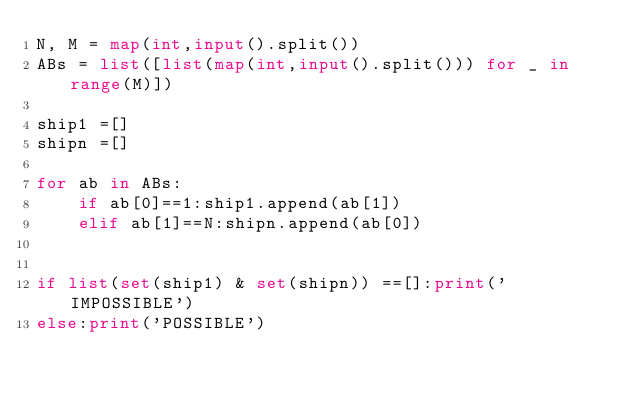Convert code to text. <code><loc_0><loc_0><loc_500><loc_500><_Python_>N, M = map(int,input().split())
ABs = list([list(map(int,input().split())) for _ in range(M)])
 
ship1 =[]
shipn =[]
 
for ab in ABs:
    if ab[0]==1:ship1.append(ab[1])
    elif ab[1]==N:shipn.append(ab[0])
 
      
if list(set(ship1) & set(shipn)) ==[]:print('IMPOSSIBLE')
else:print('POSSIBLE')
</code> 